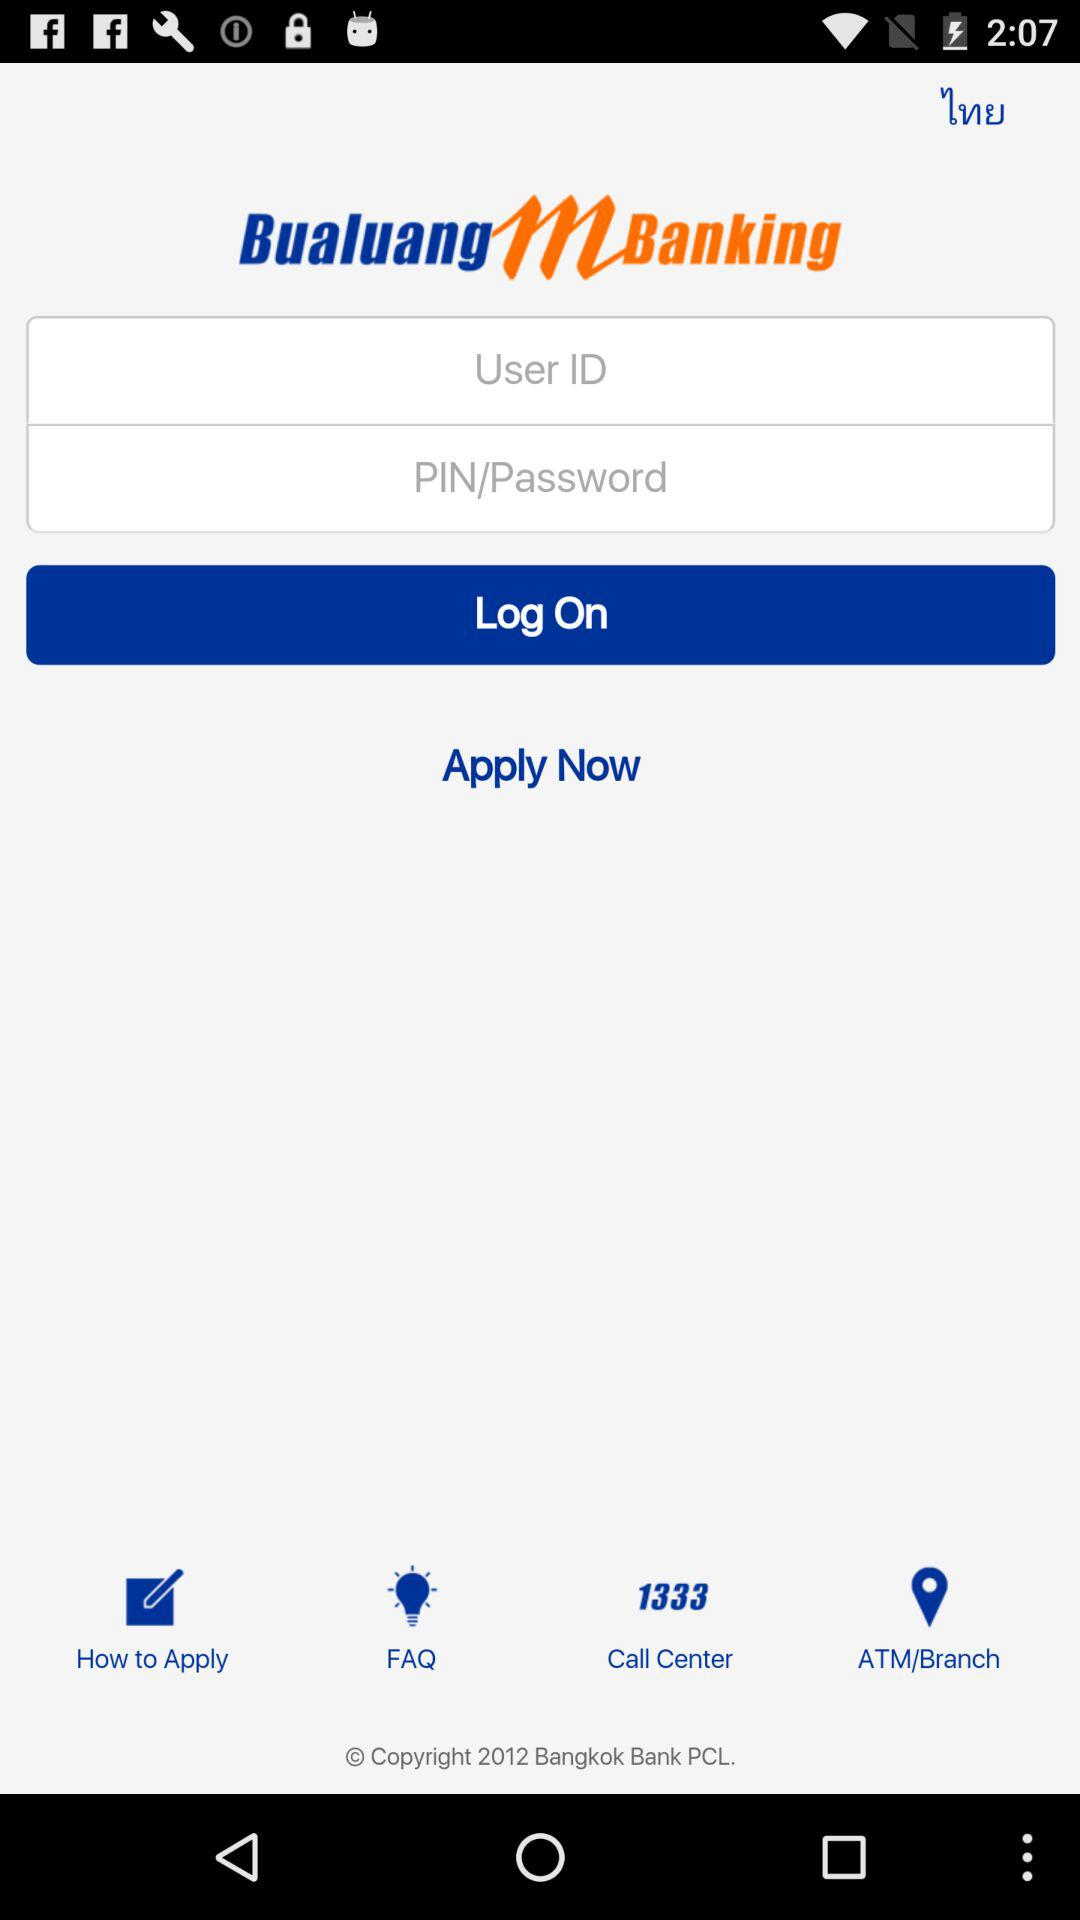What is the application name? The application name is "Bualuang mBanking". 